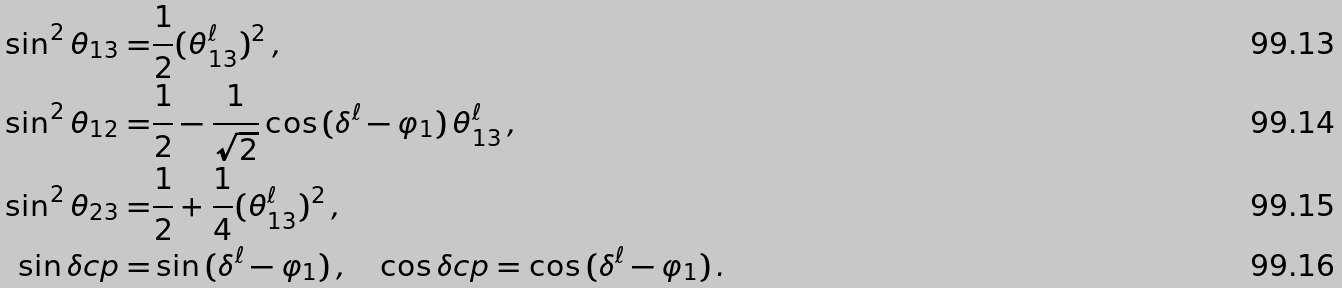<formula> <loc_0><loc_0><loc_500><loc_500>\sin ^ { 2 } \theta _ { 1 3 } = & \frac { 1 } { 2 } ( \theta ^ { \ell } _ { 1 3 } ) ^ { 2 } \, , \\ \sin ^ { 2 } \theta _ { 1 2 } = & \frac { 1 } { 2 } - \frac { 1 } { \sqrt { 2 } } \cos { ( \delta ^ { \ell } - \varphi _ { 1 } ) } \, \theta ^ { \ell } _ { 1 3 } \, , \\ \sin ^ { 2 } \theta _ { 2 3 } = & \frac { 1 } { 2 } + \frac { 1 } { 4 } ( \theta ^ { \ell } _ { 1 3 } ) ^ { 2 } \, , \\ \sin { \delta c p } = & \sin { ( \delta ^ { \ell } - \varphi _ { 1 } ) } \, , \quad \cos { \delta c p } = \cos { ( \delta ^ { \ell } - \varphi _ { 1 } ) } \, .</formula> 